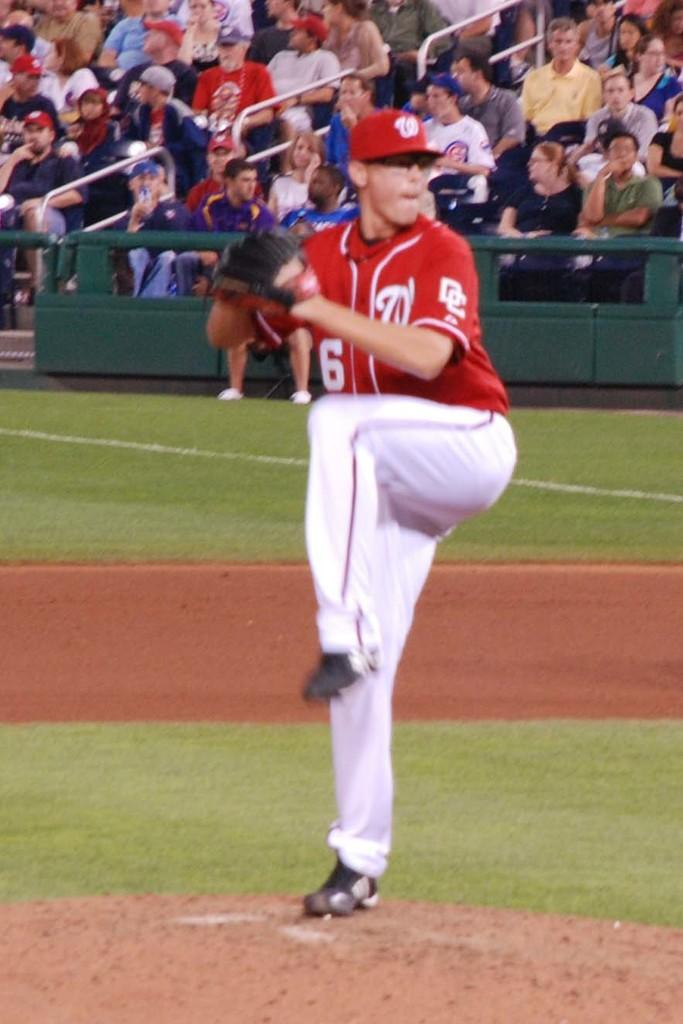Provide a one-sentence caption for the provided image. A pitcher wearing a red jersey with the letters DC on the side prepares to throw a pitch. 